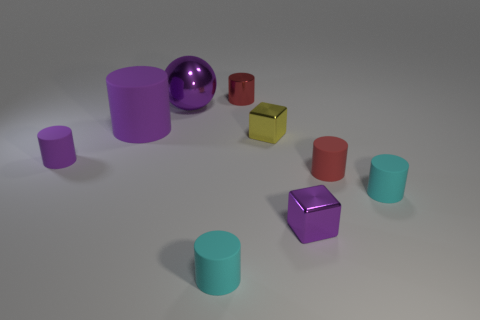Subtract all purple cylinders. How many cylinders are left? 4 Subtract all small red metallic cylinders. How many cylinders are left? 5 Subtract all blue cylinders. Subtract all green cubes. How many cylinders are left? 6 Subtract all cylinders. How many objects are left? 3 Subtract 0 blue blocks. How many objects are left? 9 Subtract all large rubber cylinders. Subtract all shiny objects. How many objects are left? 4 Add 6 small shiny blocks. How many small shiny blocks are left? 8 Add 1 cyan matte things. How many cyan matte things exist? 3 